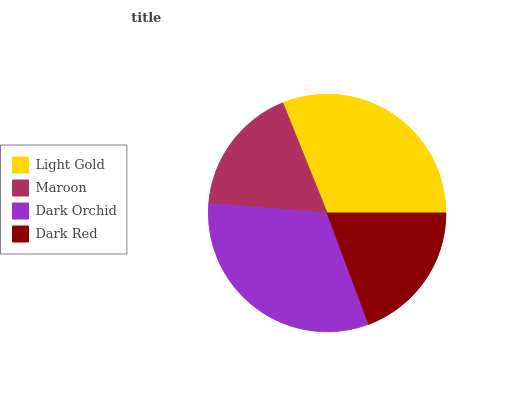Is Maroon the minimum?
Answer yes or no. Yes. Is Dark Orchid the maximum?
Answer yes or no. Yes. Is Dark Orchid the minimum?
Answer yes or no. No. Is Maroon the maximum?
Answer yes or no. No. Is Dark Orchid greater than Maroon?
Answer yes or no. Yes. Is Maroon less than Dark Orchid?
Answer yes or no. Yes. Is Maroon greater than Dark Orchid?
Answer yes or no. No. Is Dark Orchid less than Maroon?
Answer yes or no. No. Is Light Gold the high median?
Answer yes or no. Yes. Is Dark Red the low median?
Answer yes or no. Yes. Is Maroon the high median?
Answer yes or no. No. Is Light Gold the low median?
Answer yes or no. No. 